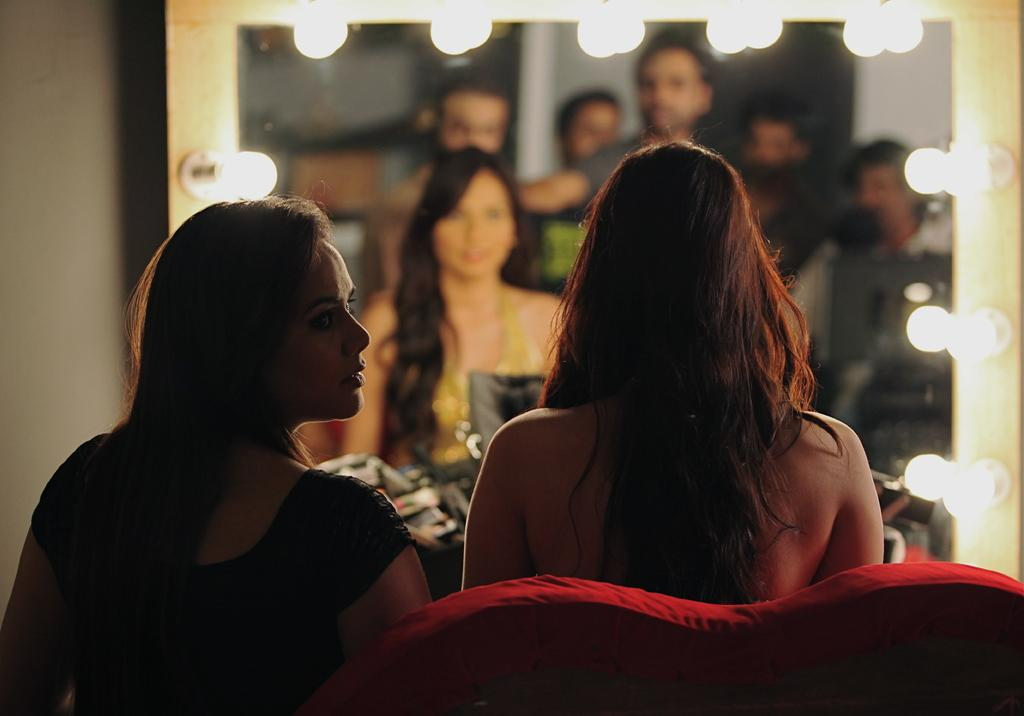What are the people in the image doing? The people in the image are seated on a sofa. What object in the image has a reflective surface? There is a mirror in the image, and people are reflected in it. What feature is present around the frame of the mirror? There are lights around the frame of the mirror. How many ducks are visible in the mirror's reflection? There are no ducks present in the image, so none can be seen in the mirror's reflection. 